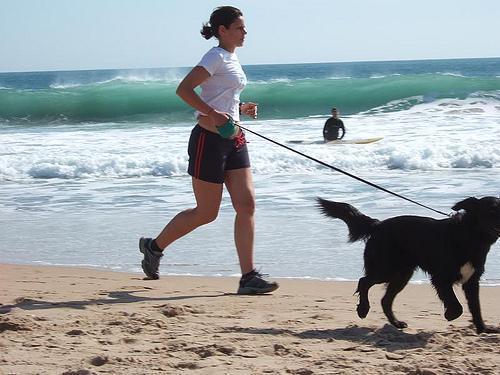How many people are shown?
Give a very brief answer. 2. How many white teddy bears in this image?
Give a very brief answer. 0. 